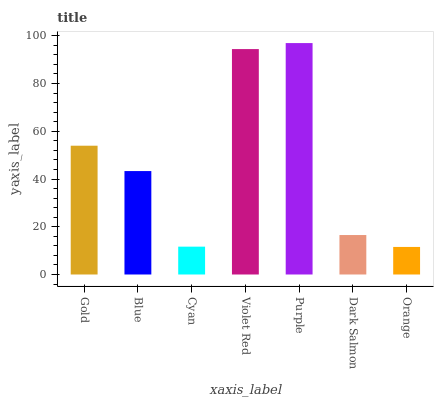Is Blue the minimum?
Answer yes or no. No. Is Blue the maximum?
Answer yes or no. No. Is Gold greater than Blue?
Answer yes or no. Yes. Is Blue less than Gold?
Answer yes or no. Yes. Is Blue greater than Gold?
Answer yes or no. No. Is Gold less than Blue?
Answer yes or no. No. Is Blue the high median?
Answer yes or no. Yes. Is Blue the low median?
Answer yes or no. Yes. Is Purple the high median?
Answer yes or no. No. Is Dark Salmon the low median?
Answer yes or no. No. 